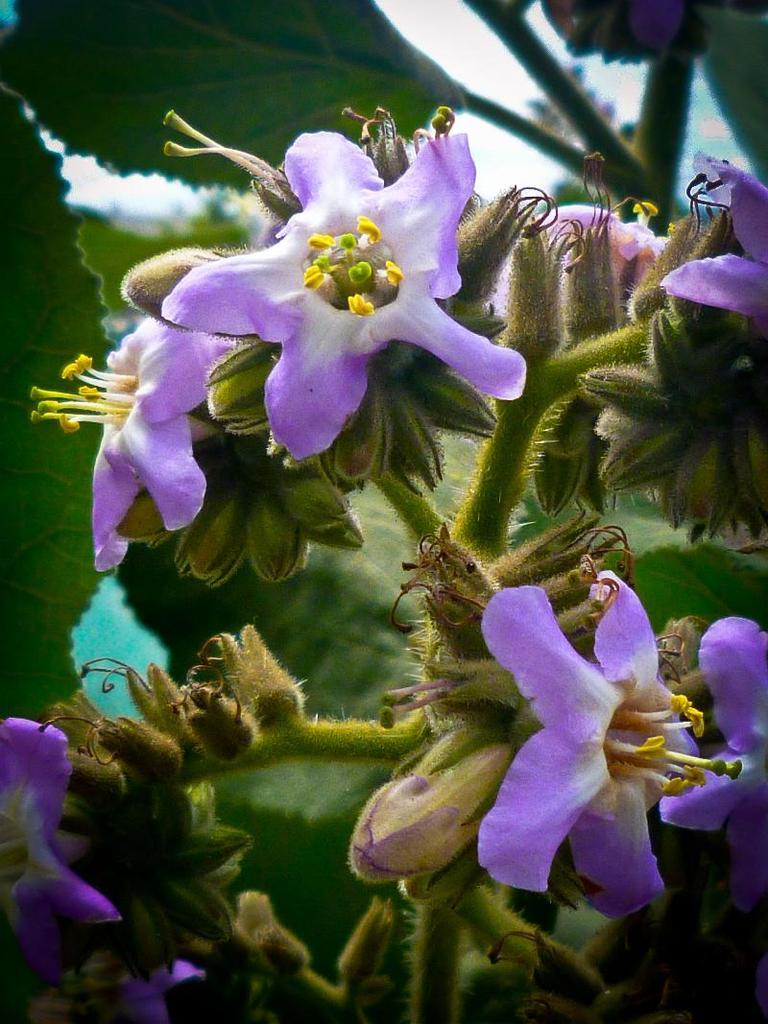What is the main subject of the image? There is a plant in the center of the image. What can be observed about the plant's flowers? The plant has flowers. Are there any other parts of the plant visible in the image? The plant has buds. What type of copper material can be seen surrounding the plant in the image? There is no copper material present in the image; it features a plant with flowers and buds. How does the frog interact with the plant in the image? There is no frog present in the image, so it cannot interact with the plant. 